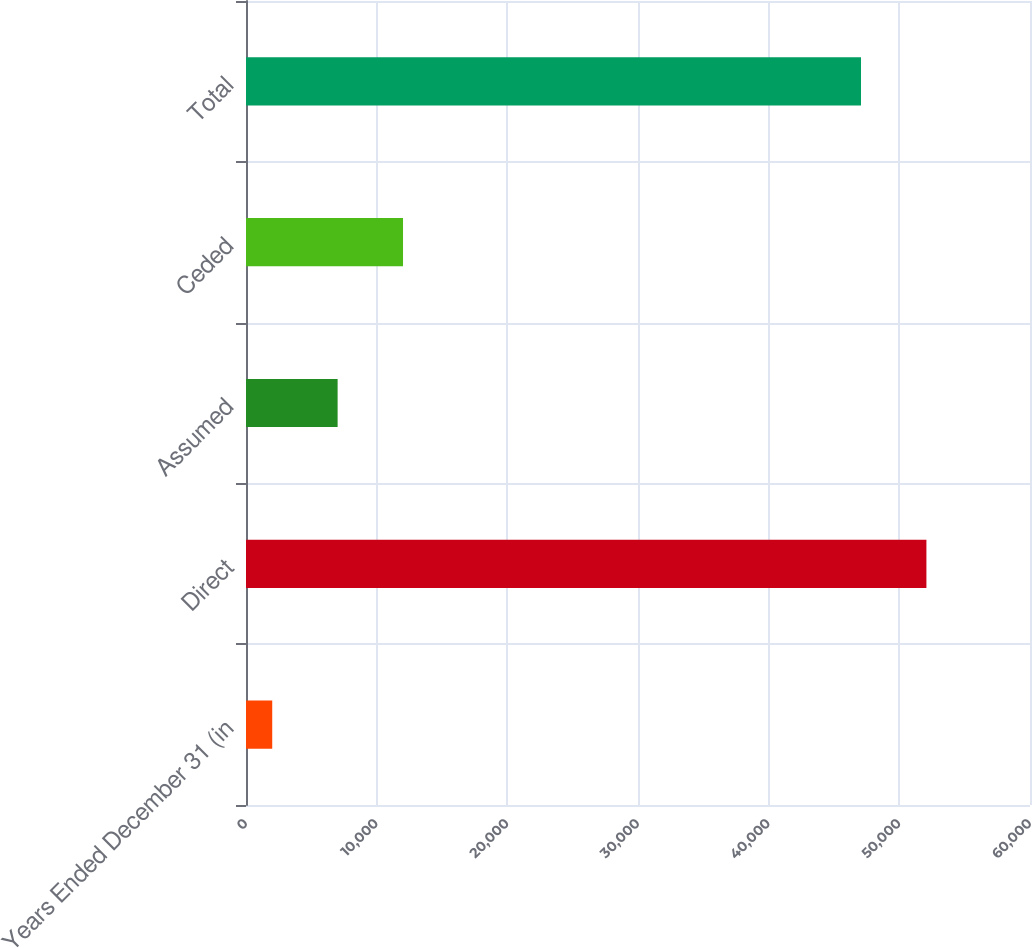<chart> <loc_0><loc_0><loc_500><loc_500><bar_chart><fcel>Years Ended December 31 (in<fcel>Direct<fcel>Assumed<fcel>Ceded<fcel>Total<nl><fcel>2007<fcel>52071.8<fcel>7011.8<fcel>12016.6<fcel>47067<nl></chart> 